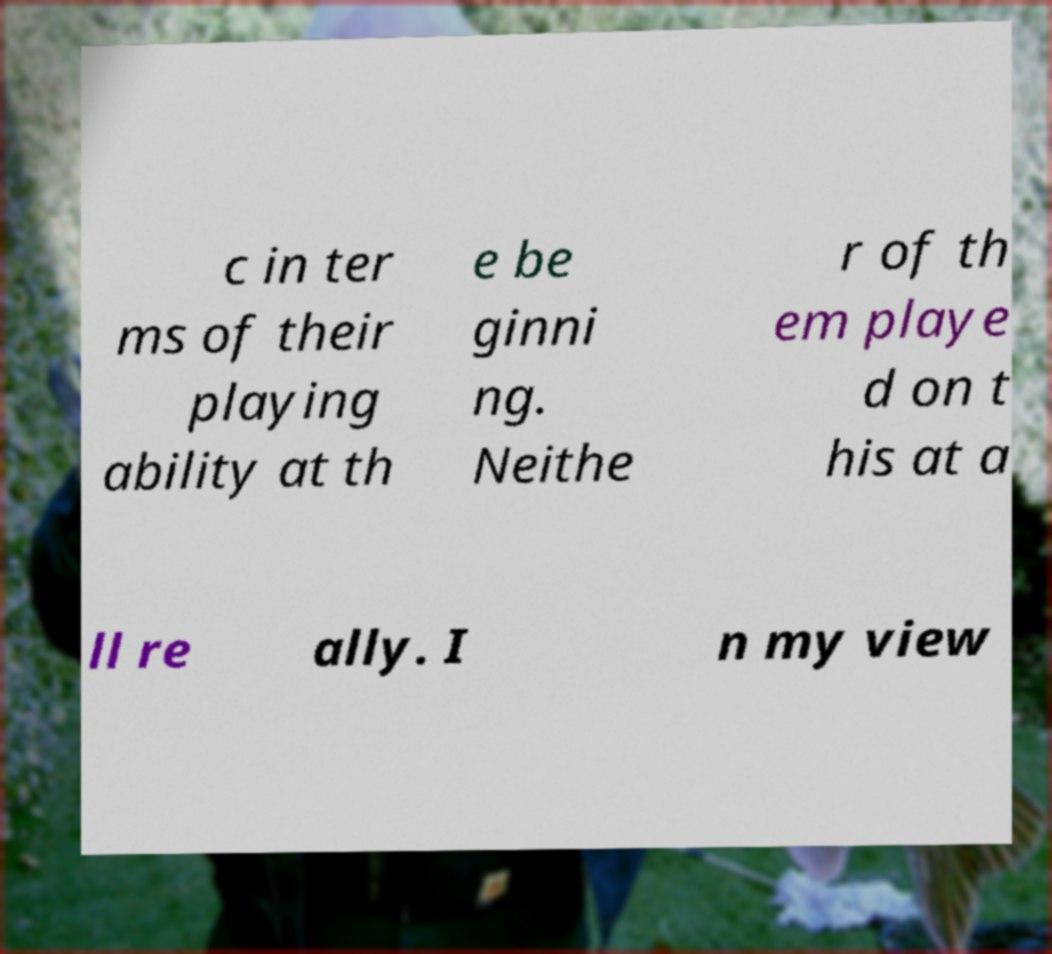Can you read and provide the text displayed in the image?This photo seems to have some interesting text. Can you extract and type it out for me? c in ter ms of their playing ability at th e be ginni ng. Neithe r of th em playe d on t his at a ll re ally. I n my view 